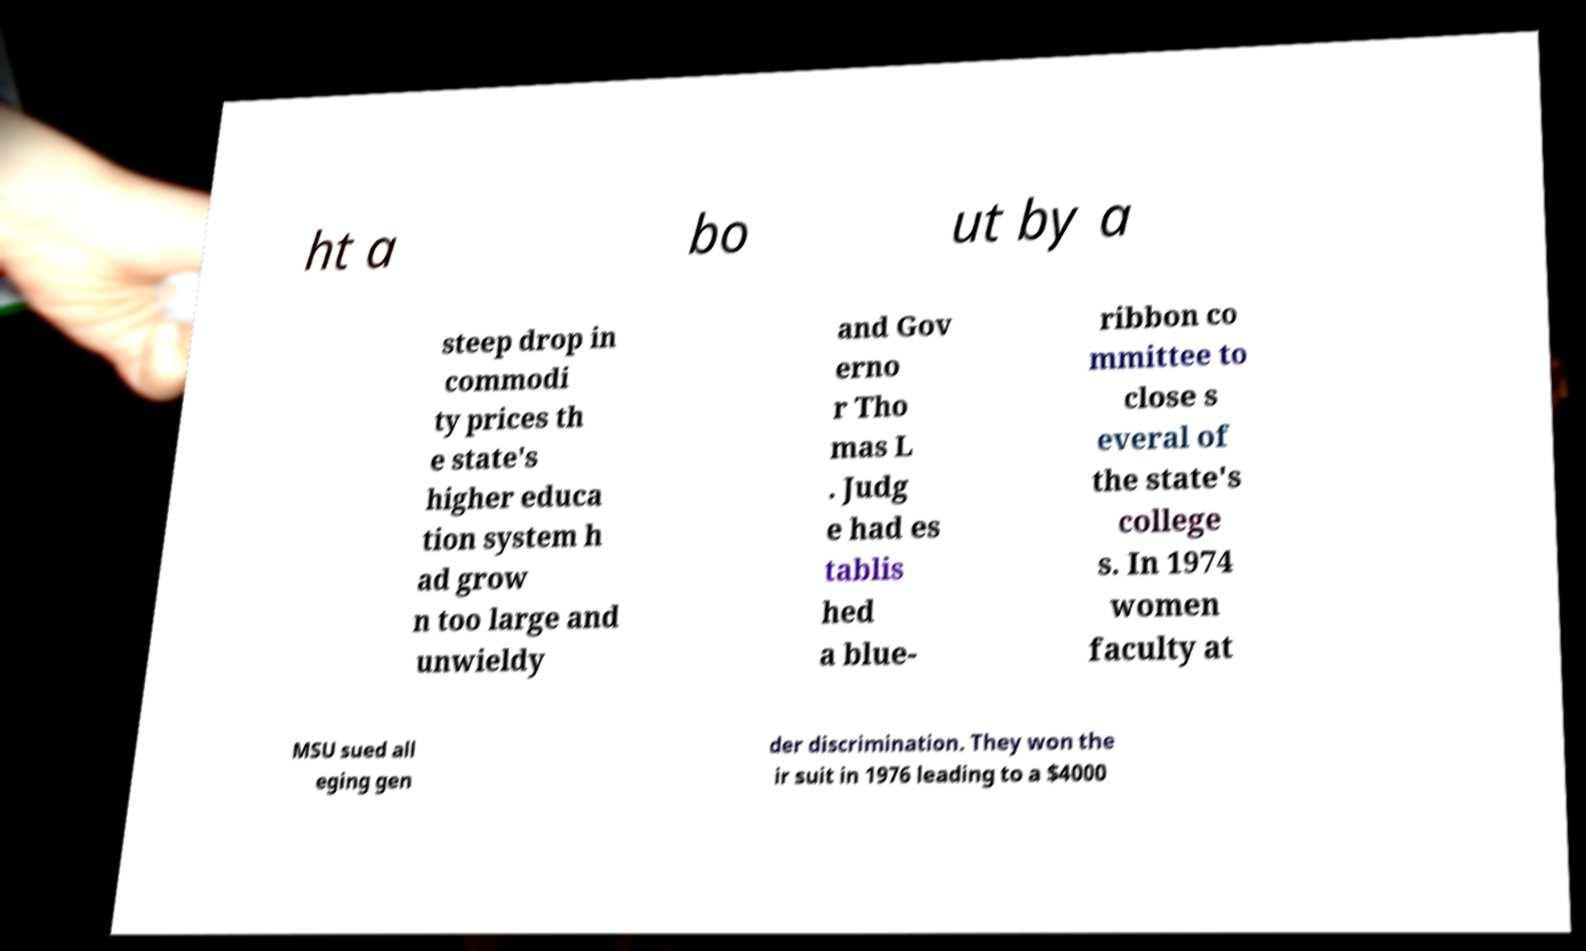Can you read and provide the text displayed in the image?This photo seems to have some interesting text. Can you extract and type it out for me? ht a bo ut by a steep drop in commodi ty prices th e state's higher educa tion system h ad grow n too large and unwieldy and Gov erno r Tho mas L . Judg e had es tablis hed a blue- ribbon co mmittee to close s everal of the state's college s. In 1974 women faculty at MSU sued all eging gen der discrimination. They won the ir suit in 1976 leading to a $4000 